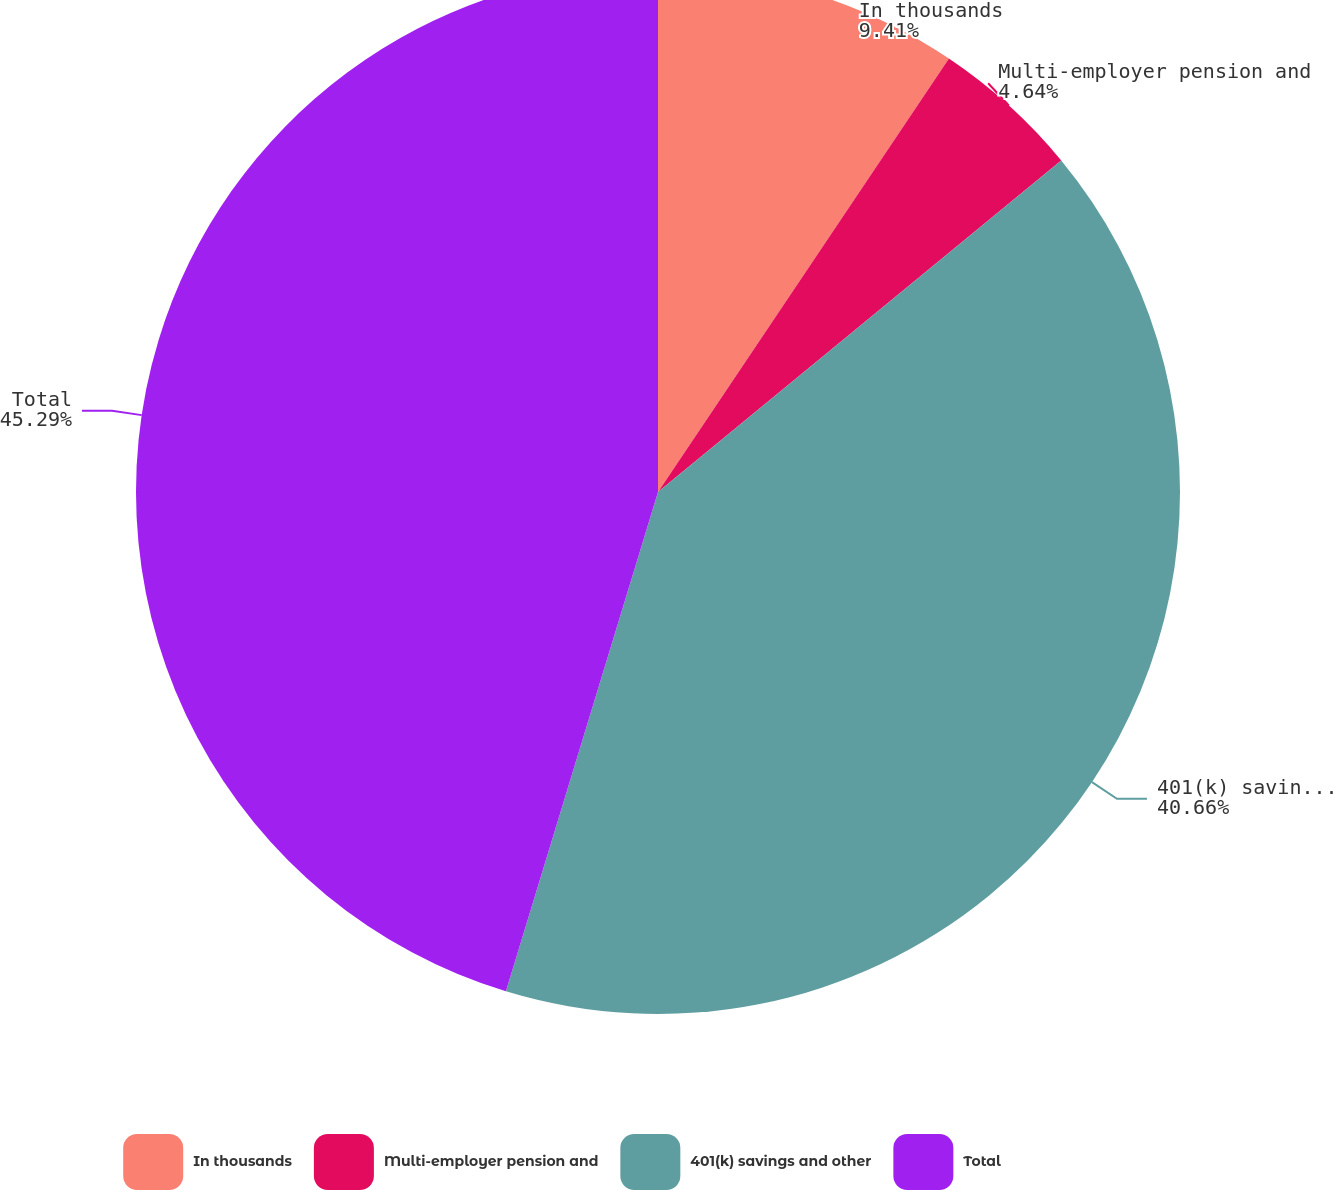Convert chart to OTSL. <chart><loc_0><loc_0><loc_500><loc_500><pie_chart><fcel>In thousands<fcel>Multi-employer pension and<fcel>401(k) savings and other<fcel>Total<nl><fcel>9.41%<fcel>4.64%<fcel>40.66%<fcel>45.3%<nl></chart> 